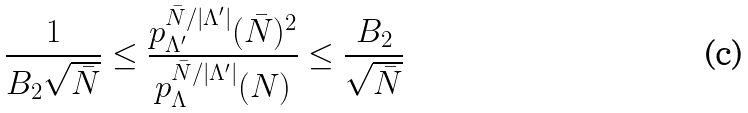Convert formula to latex. <formula><loc_0><loc_0><loc_500><loc_500>\frac { 1 } { B _ { 2 } \sqrt { \bar { N } } } \leq \frac { p _ { \Lambda ^ { \prime } } ^ { \bar { N } / | \Lambda ^ { \prime } | } ( \bar { N } ) ^ { 2 } } { p _ { \Lambda } ^ { \bar { N } / | \Lambda ^ { \prime } | } ( N ) } \leq \frac { B _ { 2 } } { \sqrt { \bar { N } } }</formula> 